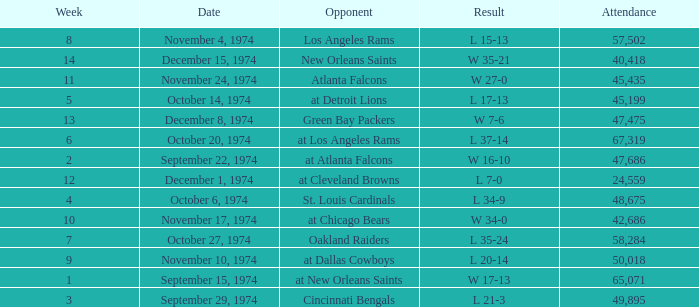Which week was the game played on December 8, 1974? 13.0. 